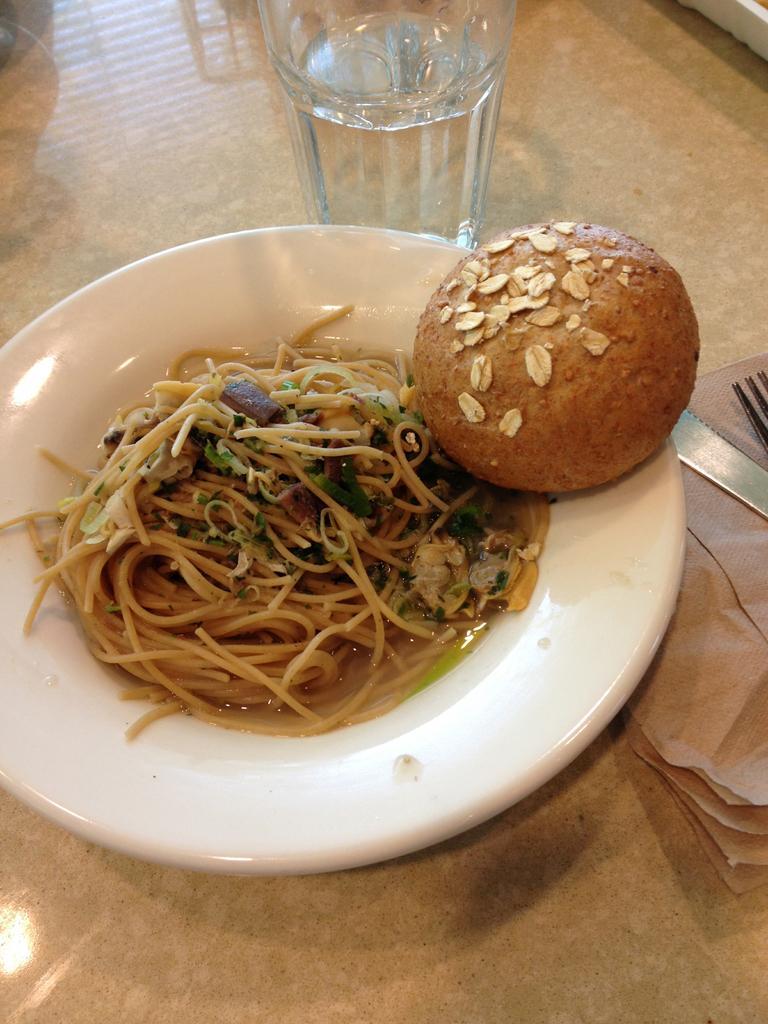In one or two sentences, can you explain what this image depicts? In this image we can see some food containing noodles and a bun in a plate placed on the table. We can also see a glass of water, a fork, a knife and some tissue papers on the table. 